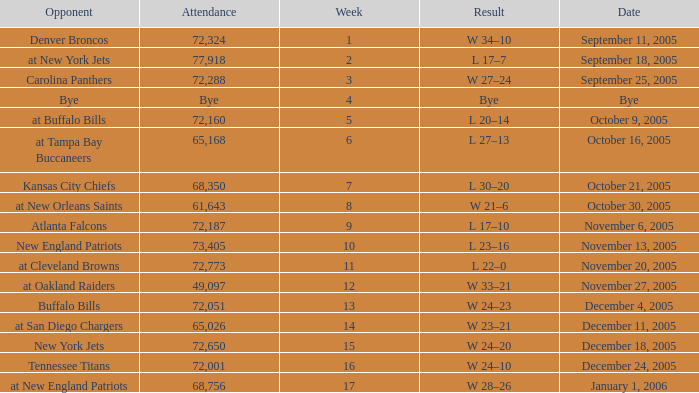On what Date was the Attendance 73,405? November 13, 2005. 